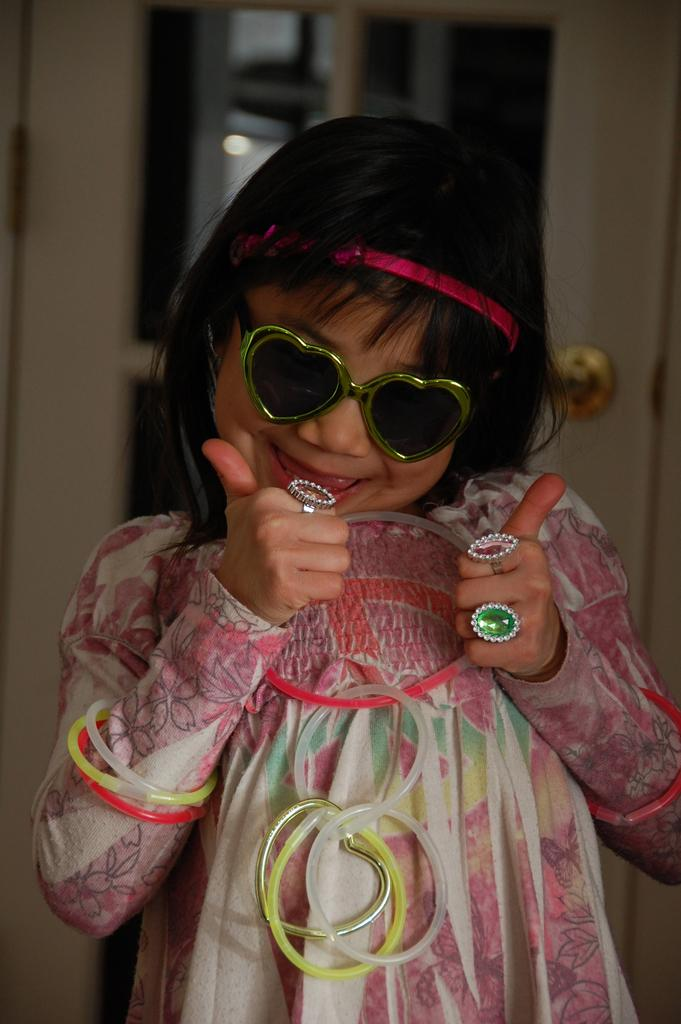Who is the main subject in the image? There is a girl in the image. What is the girl wearing on her eyes? The girl is wearing goggles. What is the girl wearing on her head? The girl is wearing a hair band. What type of jewelry is the girl wearing? The girl is wearing finger rings. What is the girl wearing as her primary clothing? The girl is wearing a dress. How would you describe the background of the image? The background of the image is blurred. Where is the shelf located in the image? There is no shelf present in the image. What type of volcano can be seen erupting in the background? There is no volcano present in the image; the background is blurred. 